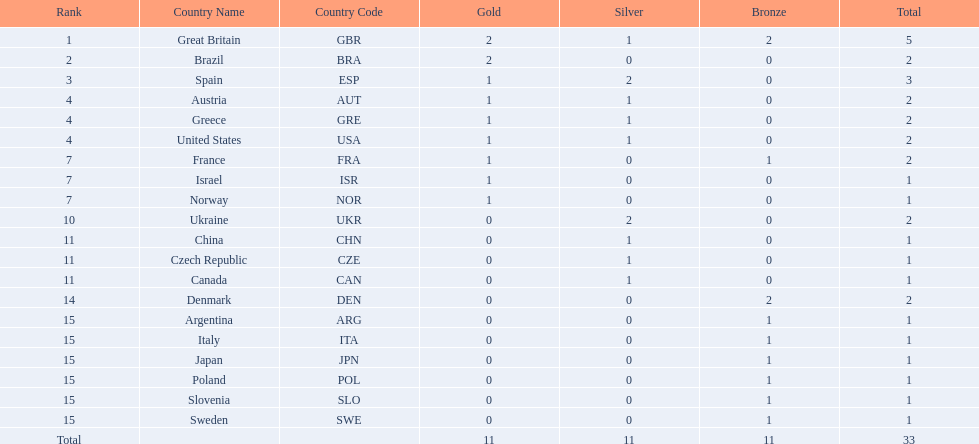What country had the most medals? Great Britain. 